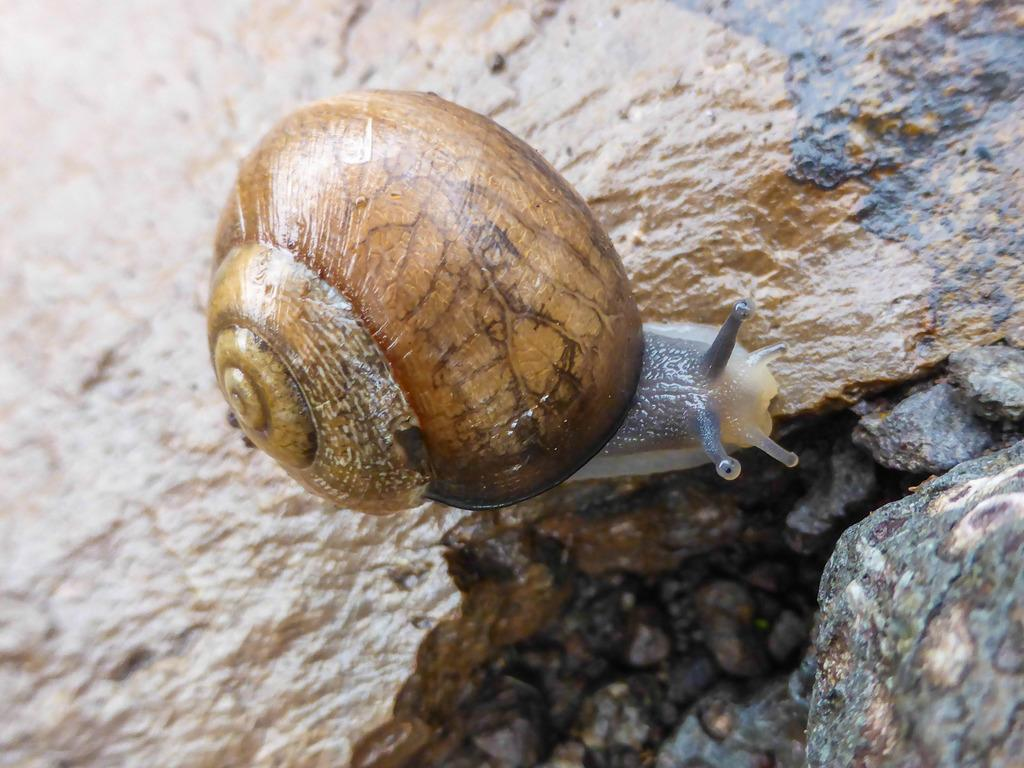What is the main subject of the image? There is a snail in the image. What is the snail doing in the image? The snail is walking on a stone in the image. What color is the snail? The snail is brown in color. What type of heart can be seen beating in the image? There is no heart visible in the image; it features a snail walking on a stone. Is there a sail visible in the image? There is no sail present in the image. 